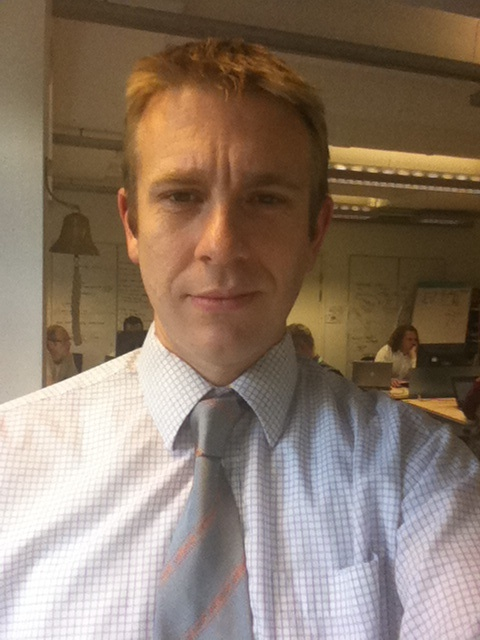Describe the objects in this image and their specific colors. I can see people in gray, lightgray, darkgray, and maroon tones, tie in gray, darkgray, and lightgray tones, people in gray, maroon, brown, black, and olive tones, people in gray, brown, and maroon tones, and laptop in gray and black tones in this image. 